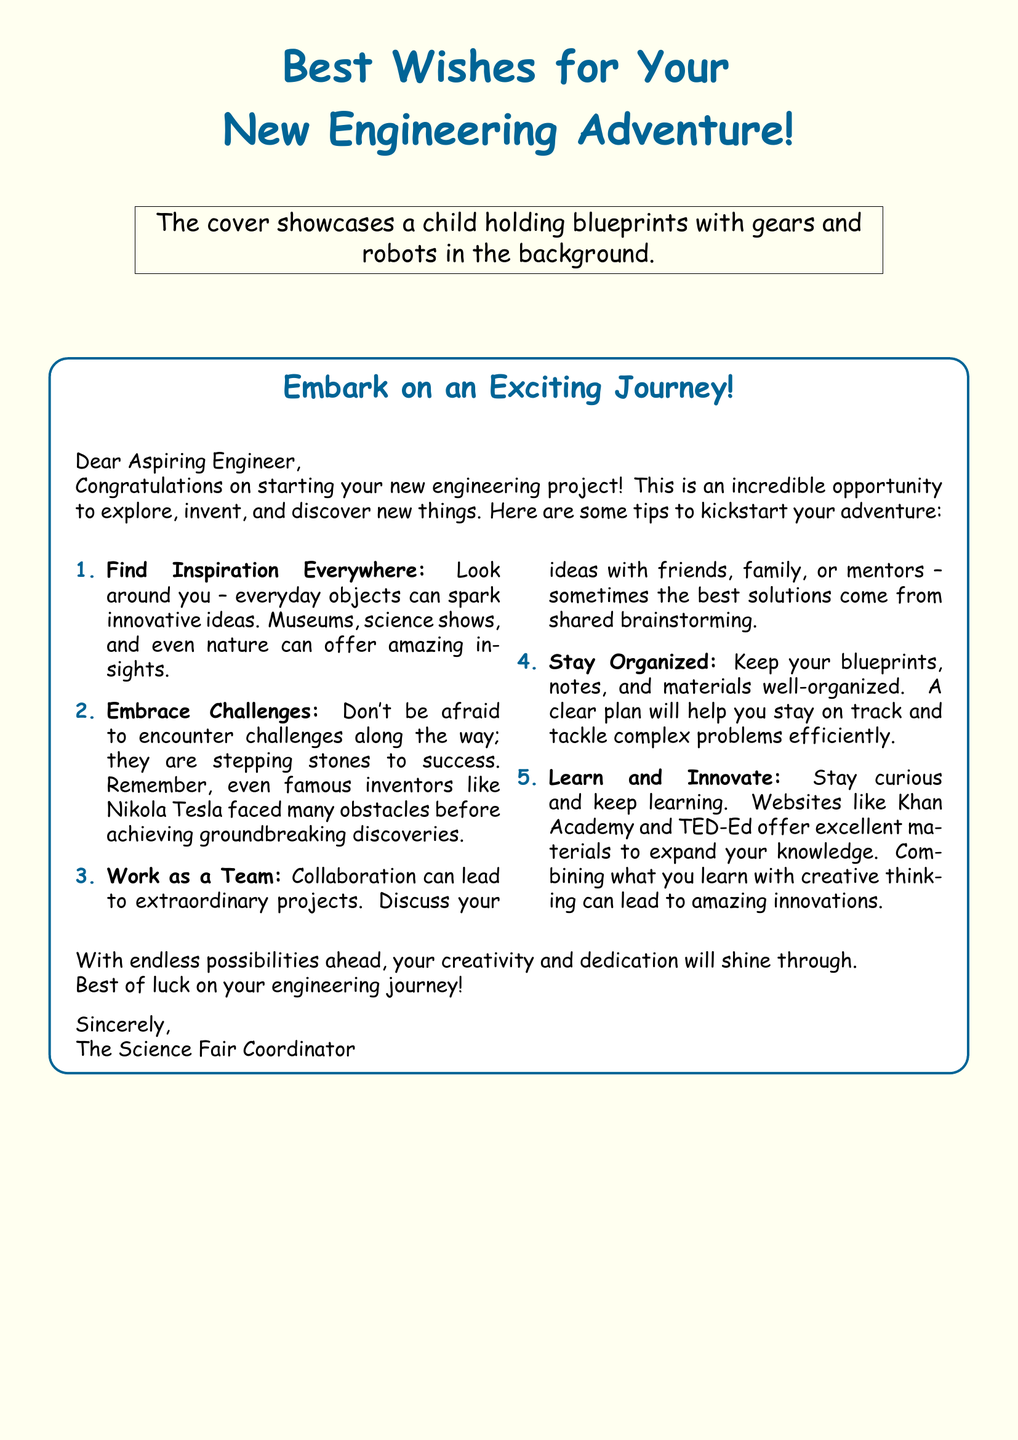What is the main theme of the greeting card? The greeting card conveys motivation and encouragement for starting an exciting new engineering project.
Answer: New Engineering Adventure Who is the intended recipient of the card? The card is designed for a child who is beginning an engineering project, thus addressing them directly as an aspiring engineer.
Answer: Aspiring Engineer How many tips are provided in the card? The card includes a list of tips to inspire and guide the recipient, revealing a specific number of suggestions.
Answer: Five What is the color of the cover background? The cover has a specific background color that can be identified visually.
Answer: Light blue What should the recipient look for to find inspiration? The card encourages the child to find inspiration in various places, indicating a range of options to explore.
Answer: Everyday objects Which famous inventor is mentioned in the card? The card references a notable figure known for his contributions to engineering and inventions, highlighting the challenges he faced.
Answer: Nikola Tesla What kind of emotion does the card convey? The overall message and design of the card are meant to evoke feelings of excitement and motivation.
Answer: Encouragement What type of activities does the card suggest for learning? The card suggests engaging in certain activities to expand knowledge relevant to engineering, detailing some options.
Answer: Websites like Khan Academy and TED-Ed What is advised to keep organized? The card emphasizes the importance of keeping certain materials in order while working on an engineering project.
Answer: Blueprints, notes, and materials 